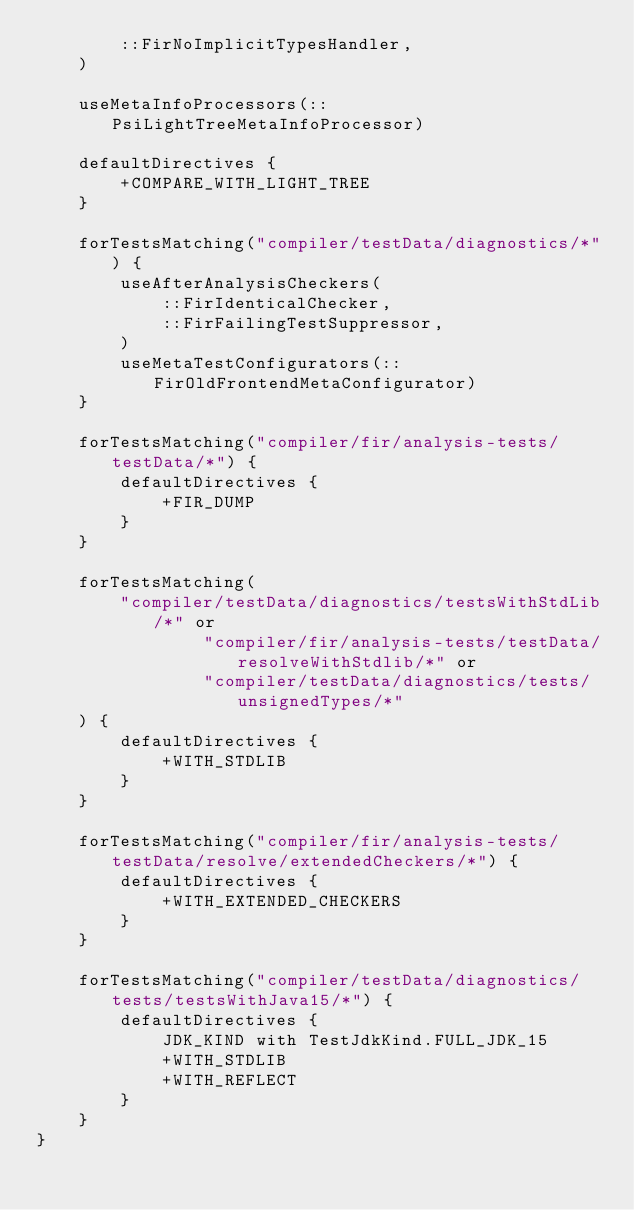Convert code to text. <code><loc_0><loc_0><loc_500><loc_500><_Kotlin_>        ::FirNoImplicitTypesHandler,
    )

    useMetaInfoProcessors(::PsiLightTreeMetaInfoProcessor)

    defaultDirectives {
        +COMPARE_WITH_LIGHT_TREE
    }

    forTestsMatching("compiler/testData/diagnostics/*") {
        useAfterAnalysisCheckers(
            ::FirIdenticalChecker,
            ::FirFailingTestSuppressor,
        )
        useMetaTestConfigurators(::FirOldFrontendMetaConfigurator)
    }

    forTestsMatching("compiler/fir/analysis-tests/testData/*") {
        defaultDirectives {
            +FIR_DUMP
        }
    }

    forTestsMatching(
        "compiler/testData/diagnostics/testsWithStdLib/*" or
                "compiler/fir/analysis-tests/testData/resolveWithStdlib/*" or
                "compiler/testData/diagnostics/tests/unsignedTypes/*"
    ) {
        defaultDirectives {
            +WITH_STDLIB
        }
    }

    forTestsMatching("compiler/fir/analysis-tests/testData/resolve/extendedCheckers/*") {
        defaultDirectives {
            +WITH_EXTENDED_CHECKERS
        }
    }

    forTestsMatching("compiler/testData/diagnostics/tests/testsWithJava15/*") {
        defaultDirectives {
            JDK_KIND with TestJdkKind.FULL_JDK_15
            +WITH_STDLIB
            +WITH_REFLECT
        }
    }
}
</code> 